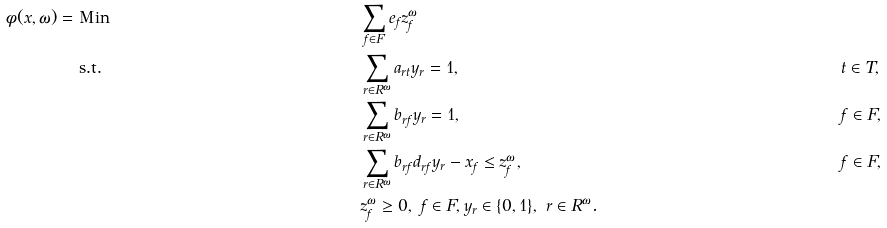<formula> <loc_0><loc_0><loc_500><loc_500>\phi ( x , \omega ) = & \text { Min } & & \sum _ { f \in F } e _ { f } z _ { f } ^ { \omega } & & & & \\ & \text { s.t. } & & \sum _ { r \in R ^ { \omega } } a _ { r t } y _ { r } = 1 , & & t \in T , \\ & & & \sum _ { r \in R ^ { \omega } } b _ { r f } y _ { r } = 1 , & & f \in F , \\ & & & \sum _ { r \in R ^ { \omega } } b _ { r f } d _ { r f } y _ { r } - x _ { f } \leq z _ { f } ^ { \omega } , & & f \in F , \\ & & & z _ { f } ^ { \omega } \geq 0 , \text { } f \in F , y _ { r } \in \{ 0 , 1 \} , \ r \in R ^ { \omega } . & &</formula> 